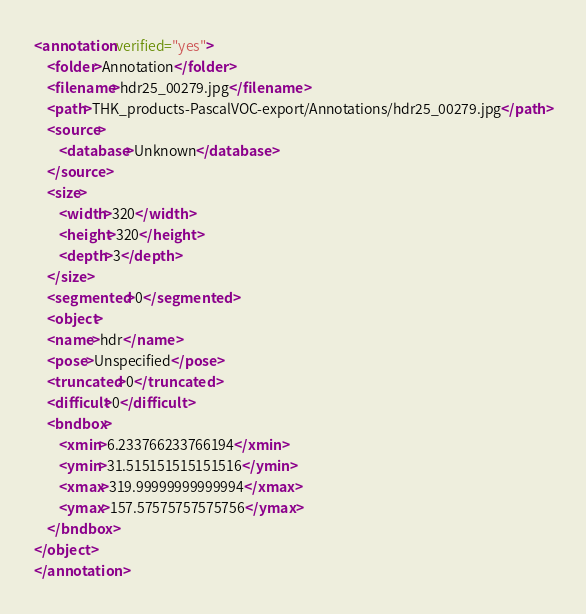Convert code to text. <code><loc_0><loc_0><loc_500><loc_500><_XML_><annotation verified="yes">
    <folder>Annotation</folder>
    <filename>hdr25_00279.jpg</filename>
    <path>THK_products-PascalVOC-export/Annotations/hdr25_00279.jpg</path>
    <source>
        <database>Unknown</database>
    </source>
    <size>
        <width>320</width>
        <height>320</height>
        <depth>3</depth>
    </size>
    <segmented>0</segmented>
    <object>
    <name>hdr</name>
    <pose>Unspecified</pose>
    <truncated>0</truncated>
    <difficult>0</difficult>
    <bndbox>
        <xmin>6.233766233766194</xmin>
        <ymin>31.515151515151516</ymin>
        <xmax>319.99999999999994</xmax>
        <ymax>157.57575757575756</ymax>
    </bndbox>
</object>
</annotation>
</code> 